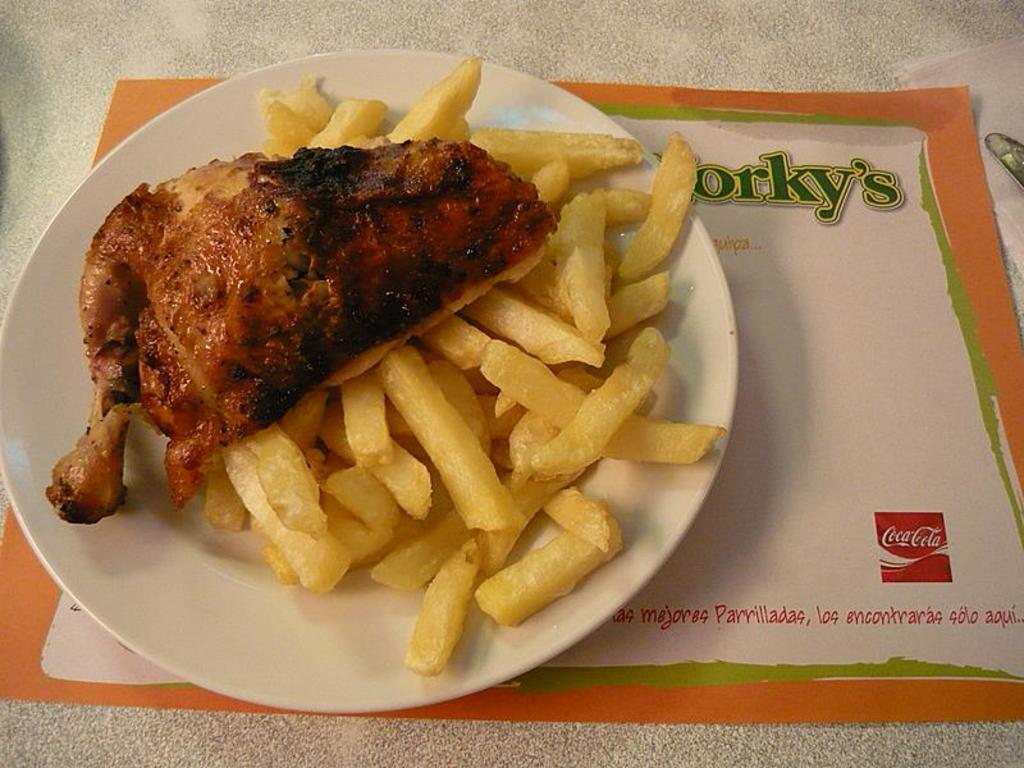What type of food is on the plate in the image? There is meat and french fries on the plate in the image. What is at the bottom of the plate? There is a paper and tissues at the bottom of the plate. What utensil is present in the image? There is a knife in the image. What type of bread is being served by the police officer in the image? There is no bread or police officer present in the image. 